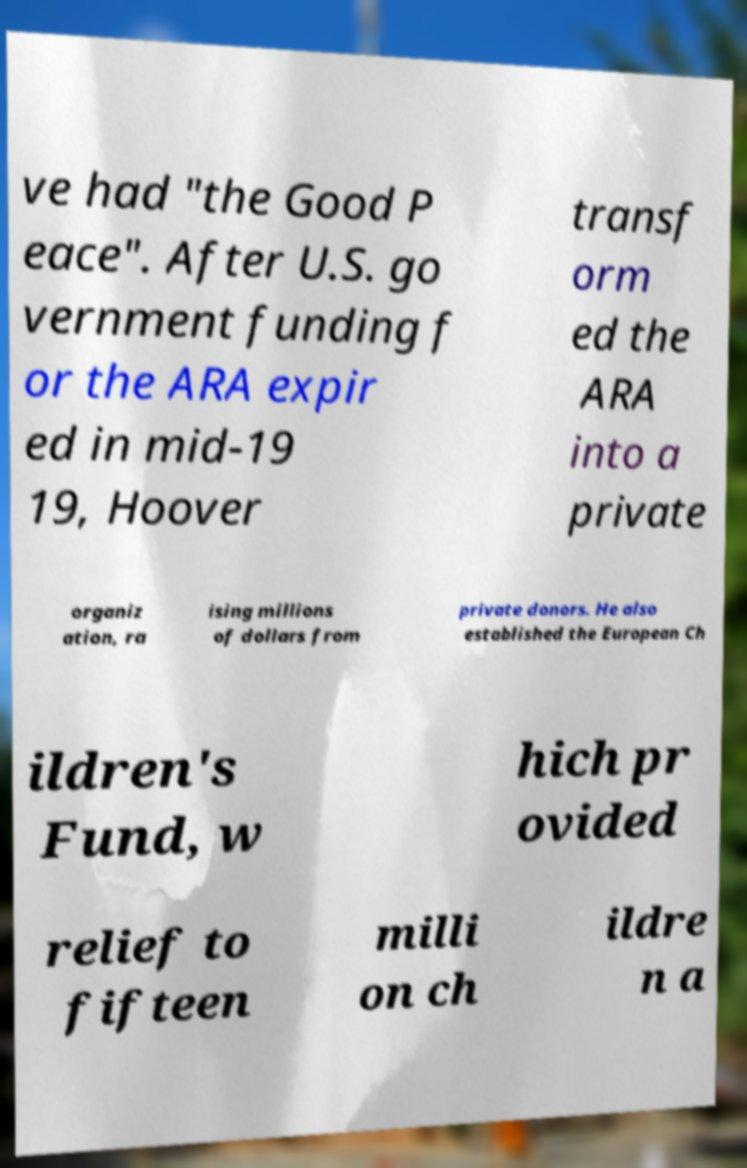Could you extract and type out the text from this image? ve had "the Good P eace". After U.S. go vernment funding f or the ARA expir ed in mid-19 19, Hoover transf orm ed the ARA into a private organiz ation, ra ising millions of dollars from private donors. He also established the European Ch ildren's Fund, w hich pr ovided relief to fifteen milli on ch ildre n a 